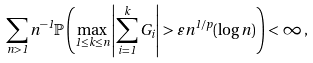<formula> <loc_0><loc_0><loc_500><loc_500>\sum _ { n > 1 } n ^ { - 1 } { \mathbb { P } } \left ( \max _ { 1 \leq k \leq n } \left | \sum _ { i = 1 } ^ { k } G _ { i } \right | > \varepsilon n ^ { 1 / p } ( \log n ) \right ) < \infty \, ,</formula> 